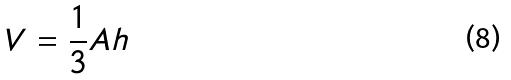Convert formula to latex. <formula><loc_0><loc_0><loc_500><loc_500>V = \frac { 1 } { 3 } A h</formula> 